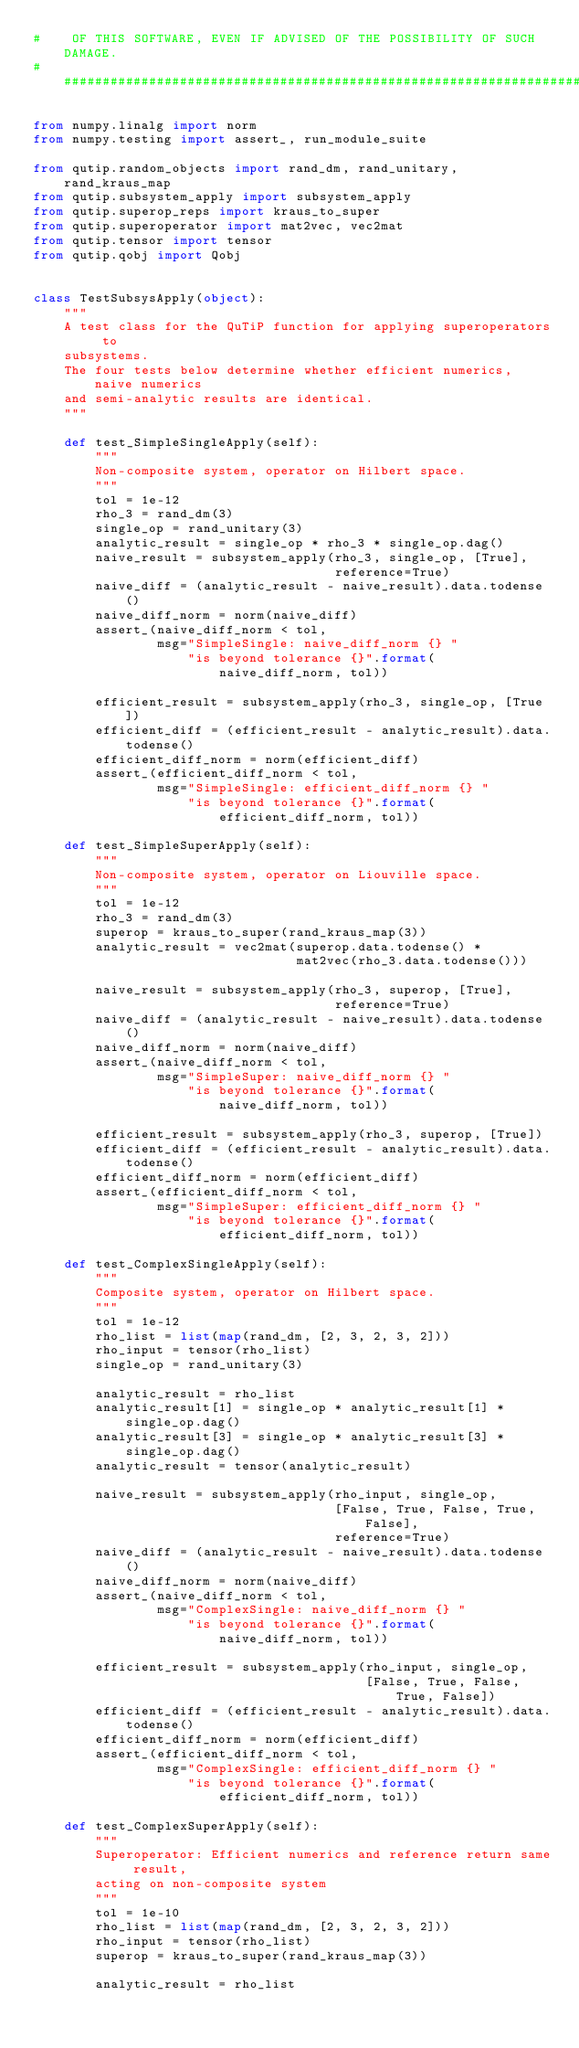<code> <loc_0><loc_0><loc_500><loc_500><_Python_>#    OF THIS SOFTWARE, EVEN IF ADVISED OF THE POSSIBILITY OF SUCH DAMAGE.
###############################################################################

from numpy.linalg import norm
from numpy.testing import assert_, run_module_suite

from qutip.random_objects import rand_dm, rand_unitary, rand_kraus_map
from qutip.subsystem_apply import subsystem_apply
from qutip.superop_reps import kraus_to_super
from qutip.superoperator import mat2vec, vec2mat
from qutip.tensor import tensor
from qutip.qobj import Qobj


class TestSubsysApply(object):
    """
    A test class for the QuTiP function for applying superoperators to
    subsystems.
    The four tests below determine whether efficient numerics, naive numerics
    and semi-analytic results are identical.
    """

    def test_SimpleSingleApply(self):
        """
        Non-composite system, operator on Hilbert space.
        """
        tol = 1e-12
        rho_3 = rand_dm(3)
        single_op = rand_unitary(3)
        analytic_result = single_op * rho_3 * single_op.dag()
        naive_result = subsystem_apply(rho_3, single_op, [True],
                                       reference=True)
        naive_diff = (analytic_result - naive_result).data.todense()
        naive_diff_norm = norm(naive_diff)
        assert_(naive_diff_norm < tol,
                msg="SimpleSingle: naive_diff_norm {} "
                    "is beyond tolerance {}".format(
                        naive_diff_norm, tol))
                                       
        efficient_result = subsystem_apply(rho_3, single_op, [True])
        efficient_diff = (efficient_result - analytic_result).data.todense()
        efficient_diff_norm = norm(efficient_diff)
        assert_(efficient_diff_norm < tol,
                msg="SimpleSingle: efficient_diff_norm {} "
                    "is beyond tolerance {}".format(
                        efficient_diff_norm, tol))

    def test_SimpleSuperApply(self):
        """
        Non-composite system, operator on Liouville space.
        """
        tol = 1e-12
        rho_3 = rand_dm(3)
        superop = kraus_to_super(rand_kraus_map(3))
        analytic_result = vec2mat(superop.data.todense() *
                                  mat2vec(rho_3.data.todense()))

        naive_result = subsystem_apply(rho_3, superop, [True],
                                       reference=True)
        naive_diff = (analytic_result - naive_result).data.todense()
        naive_diff_norm = norm(naive_diff)
        assert_(naive_diff_norm < tol,
                msg="SimpleSuper: naive_diff_norm {} "
                    "is beyond tolerance {}".format(
                        naive_diff_norm, tol))

        efficient_result = subsystem_apply(rho_3, superop, [True])
        efficient_diff = (efficient_result - analytic_result).data.todense()
        efficient_diff_norm = norm(efficient_diff)
        assert_(efficient_diff_norm < tol,
                msg="SimpleSuper: efficient_diff_norm {} "
                    "is beyond tolerance {}".format(
                        efficient_diff_norm, tol))

    def test_ComplexSingleApply(self):
        """
        Composite system, operator on Hilbert space.
        """
        tol = 1e-12
        rho_list = list(map(rand_dm, [2, 3, 2, 3, 2]))
        rho_input = tensor(rho_list)
        single_op = rand_unitary(3)

        analytic_result = rho_list
        analytic_result[1] = single_op * analytic_result[1] * single_op.dag()
        analytic_result[3] = single_op * analytic_result[3] * single_op.dag()
        analytic_result = tensor(analytic_result)

        naive_result = subsystem_apply(rho_input, single_op,
                                       [False, True, False, True, False],
                                       reference=True)
        naive_diff = (analytic_result - naive_result).data.todense()
        naive_diff_norm = norm(naive_diff)
        assert_(naive_diff_norm < tol,
                msg="ComplexSingle: naive_diff_norm {} "
                    "is beyond tolerance {}".format(
                        naive_diff_norm, tol))

        efficient_result = subsystem_apply(rho_input, single_op,
                                           [False, True, False, True, False])
        efficient_diff = (efficient_result - analytic_result).data.todense()
        efficient_diff_norm = norm(efficient_diff)
        assert_(efficient_diff_norm < tol,
                msg="ComplexSingle: efficient_diff_norm {} "
                    "is beyond tolerance {}".format(
                        efficient_diff_norm, tol))

    def test_ComplexSuperApply(self):
        """
        Superoperator: Efficient numerics and reference return same result,
        acting on non-composite system
        """
        tol = 1e-10
        rho_list = list(map(rand_dm, [2, 3, 2, 3, 2]))
        rho_input = tensor(rho_list)
        superop = kraus_to_super(rand_kraus_map(3))
        
        analytic_result = rho_list</code> 